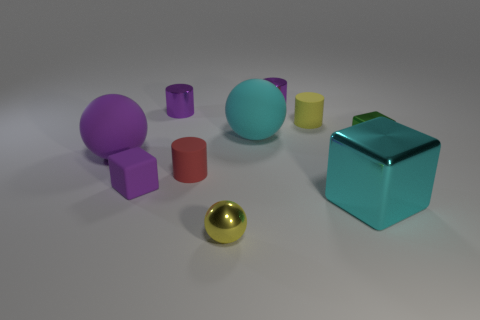Subtract 1 cylinders. How many cylinders are left? 3 Subtract all cylinders. How many objects are left? 6 Subtract 0 blue spheres. How many objects are left? 10 Subtract all tiny matte cylinders. Subtract all shiny things. How many objects are left? 3 Add 6 tiny purple cylinders. How many tiny purple cylinders are left? 8 Add 3 tiny brown shiny cubes. How many tiny brown shiny cubes exist? 3 